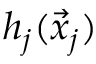<formula> <loc_0><loc_0><loc_500><loc_500>h _ { j } ( \vec { x } _ { j } )</formula> 